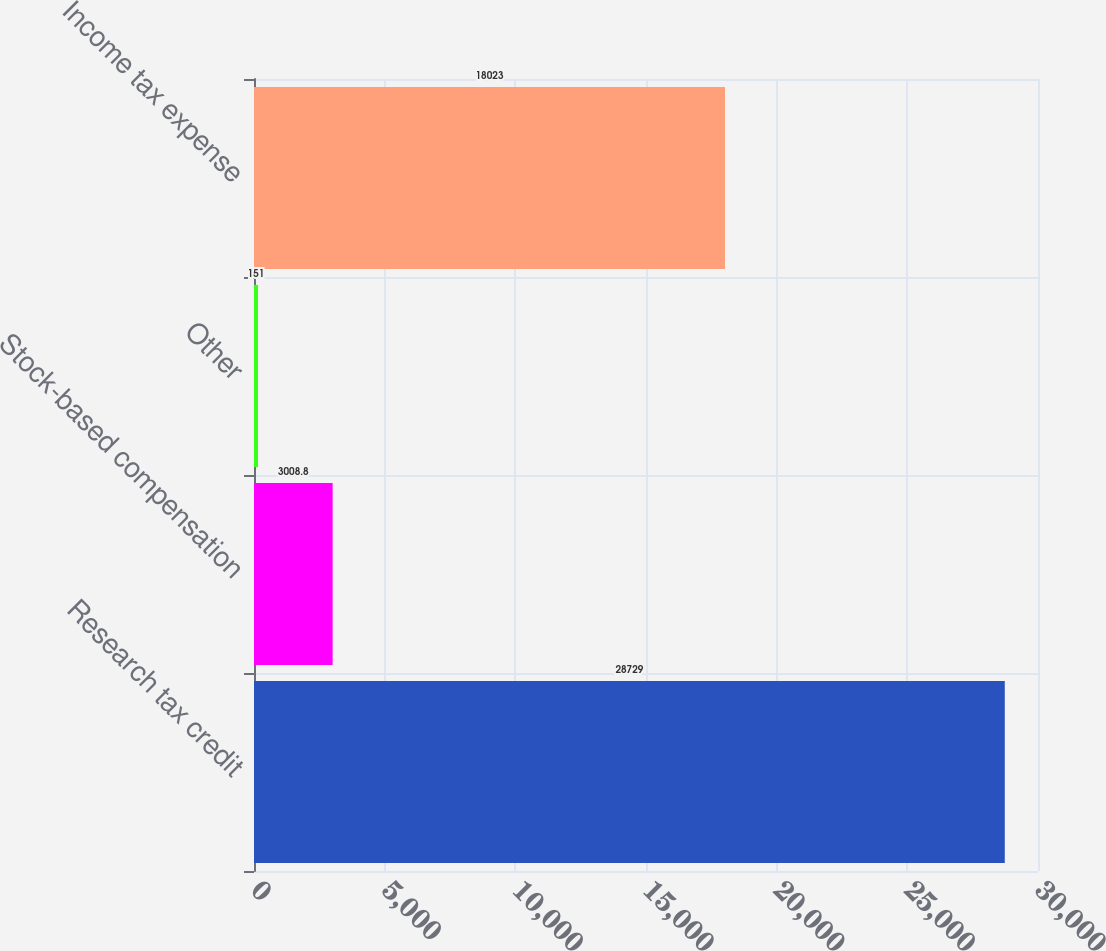<chart> <loc_0><loc_0><loc_500><loc_500><bar_chart><fcel>Research tax credit<fcel>Stock-based compensation<fcel>Other<fcel>Income tax expense<nl><fcel>28729<fcel>3008.8<fcel>151<fcel>18023<nl></chart> 